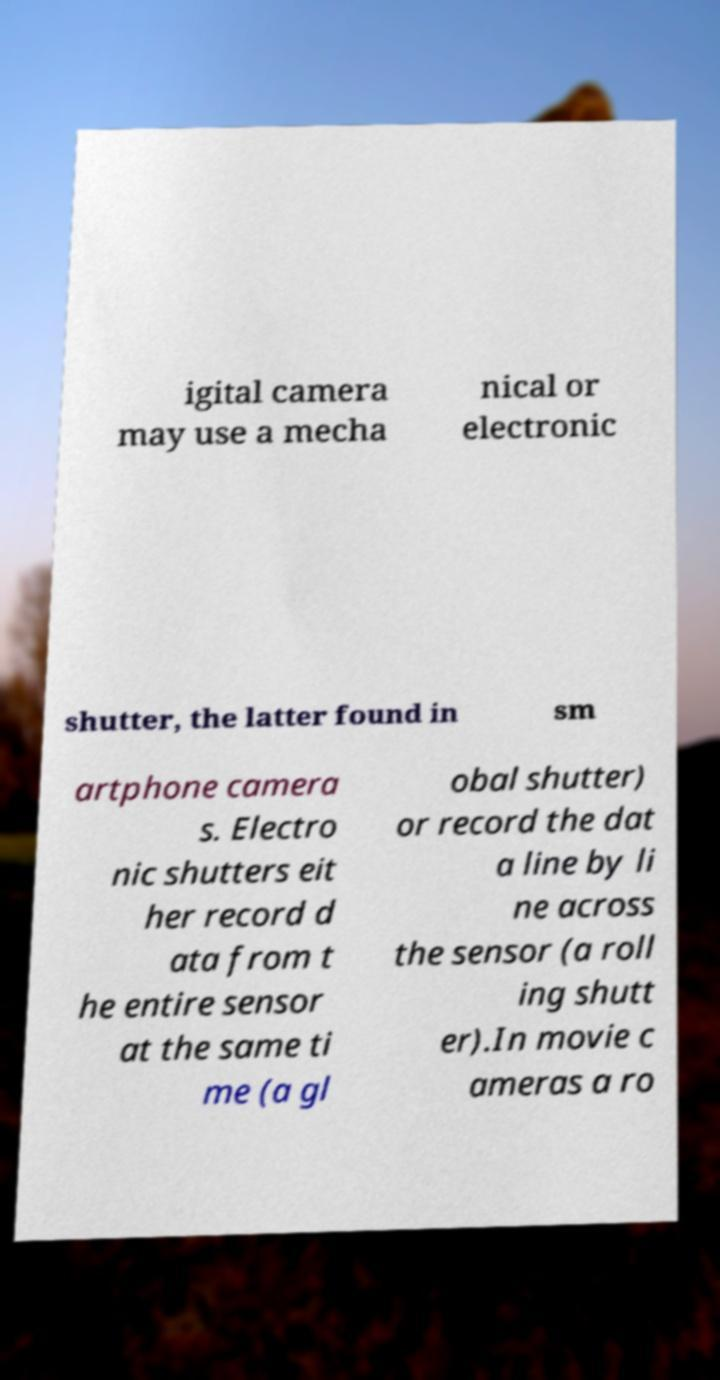Could you assist in decoding the text presented in this image and type it out clearly? igital camera may use a mecha nical or electronic shutter, the latter found in sm artphone camera s. Electro nic shutters eit her record d ata from t he entire sensor at the same ti me (a gl obal shutter) or record the dat a line by li ne across the sensor (a roll ing shutt er).In movie c ameras a ro 